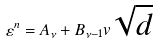Convert formula to latex. <formula><loc_0><loc_0><loc_500><loc_500>\varepsilon ^ { n } = A _ { \nu } + B _ { \nu - 1 } v \sqrt { d }</formula> 